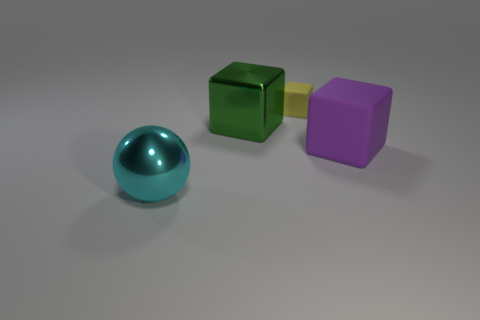Is the large green metal thing the same shape as the large purple matte thing?
Your answer should be very brief. Yes. The big cube that is on the left side of the cube that is in front of the green shiny object is what color?
Provide a succinct answer. Green. What is the color of the other matte thing that is the same size as the cyan object?
Your answer should be compact. Purple. How many metallic objects are either balls or large red spheres?
Provide a short and direct response. 1. There is a large metallic thing that is behind the cyan thing; what number of cubes are in front of it?
Provide a short and direct response. 1. What number of objects are blue shiny cylinders or large cubes on the left side of the yellow block?
Offer a very short reply. 1. Is there a big object that has the same material as the tiny block?
Your answer should be compact. Yes. What number of things are both in front of the green cube and left of the yellow matte cube?
Your response must be concise. 1. There is a large block right of the tiny yellow matte object; what is it made of?
Your answer should be compact. Rubber. There is a yellow cube that is the same material as the big purple cube; what size is it?
Make the answer very short. Small. 